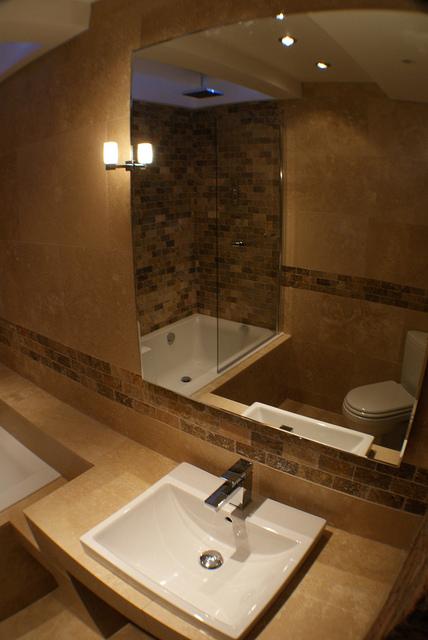What is reflected in the mirror?
Be succinct. Bathroom. Do dogs clean their paws in the sink?
Be succinct. No. What color is the sink?
Write a very short answer. White. 